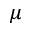<formula> <loc_0><loc_0><loc_500><loc_500>\mu</formula> 